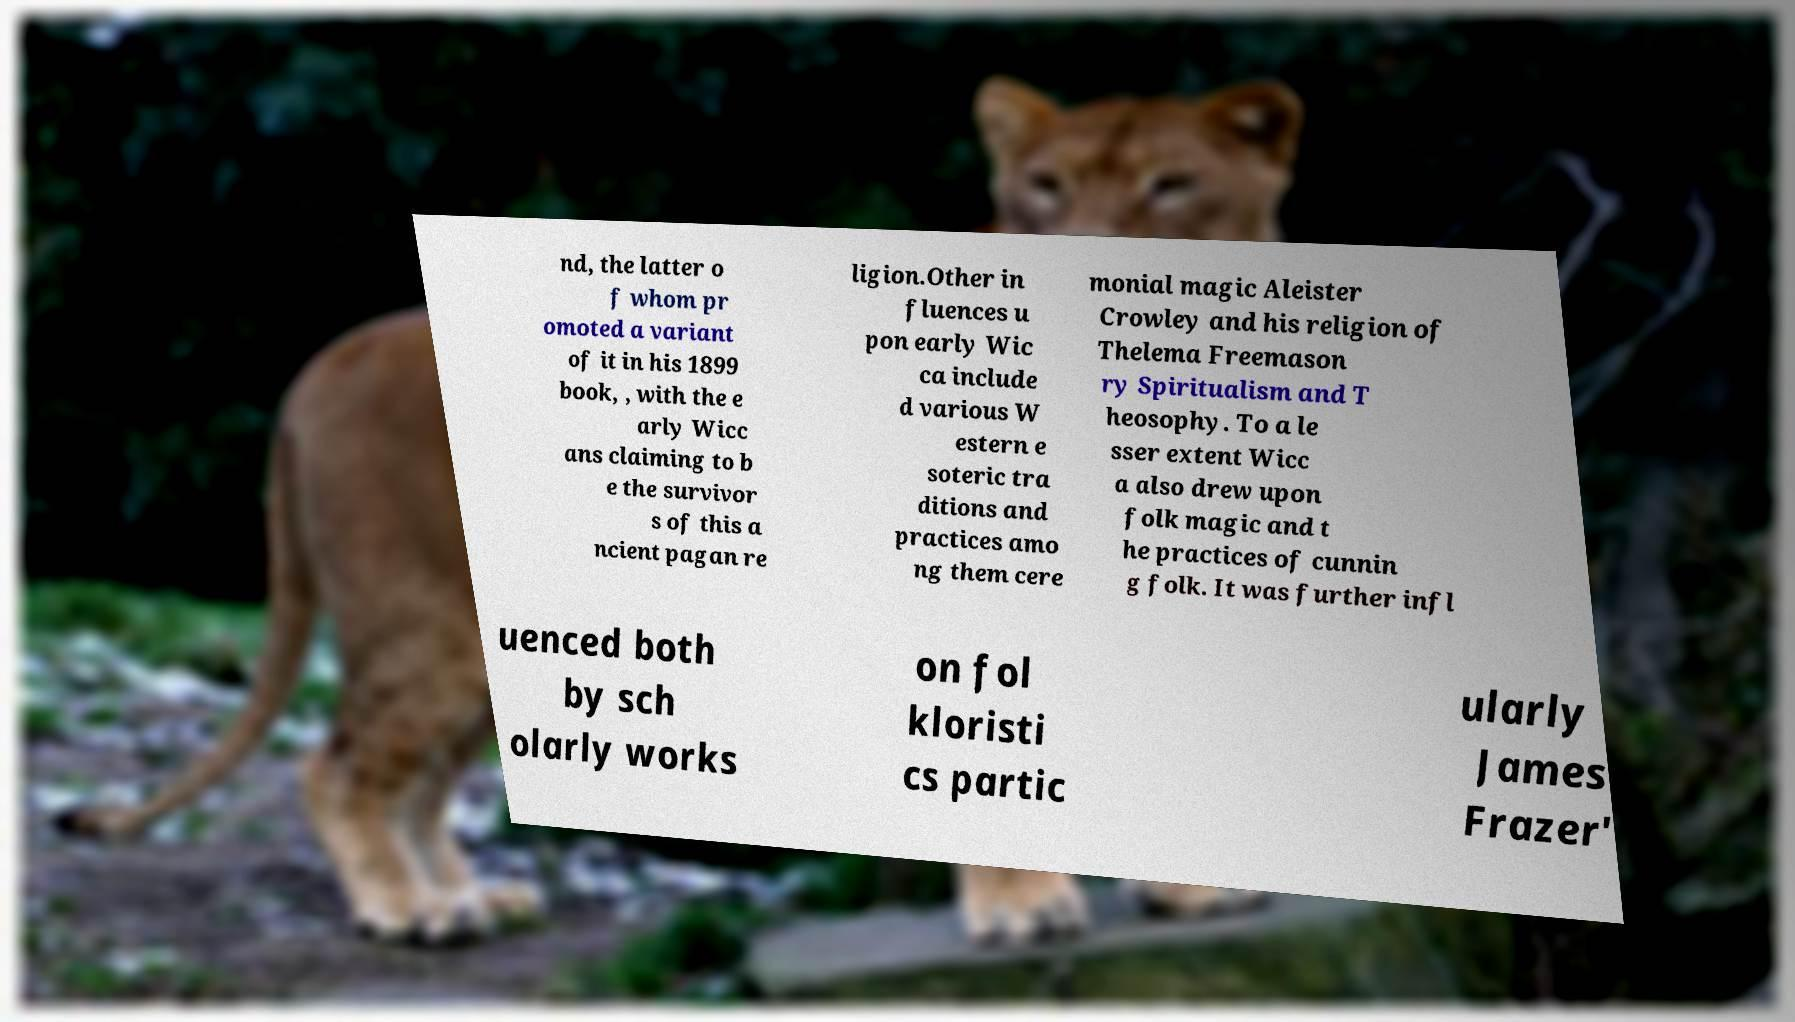Please read and relay the text visible in this image. What does it say? nd, the latter o f whom pr omoted a variant of it in his 1899 book, , with the e arly Wicc ans claiming to b e the survivor s of this a ncient pagan re ligion.Other in fluences u pon early Wic ca include d various W estern e soteric tra ditions and practices amo ng them cere monial magic Aleister Crowley and his religion of Thelema Freemason ry Spiritualism and T heosophy. To a le sser extent Wicc a also drew upon folk magic and t he practices of cunnin g folk. It was further infl uenced both by sch olarly works on fol kloristi cs partic ularly James Frazer' 